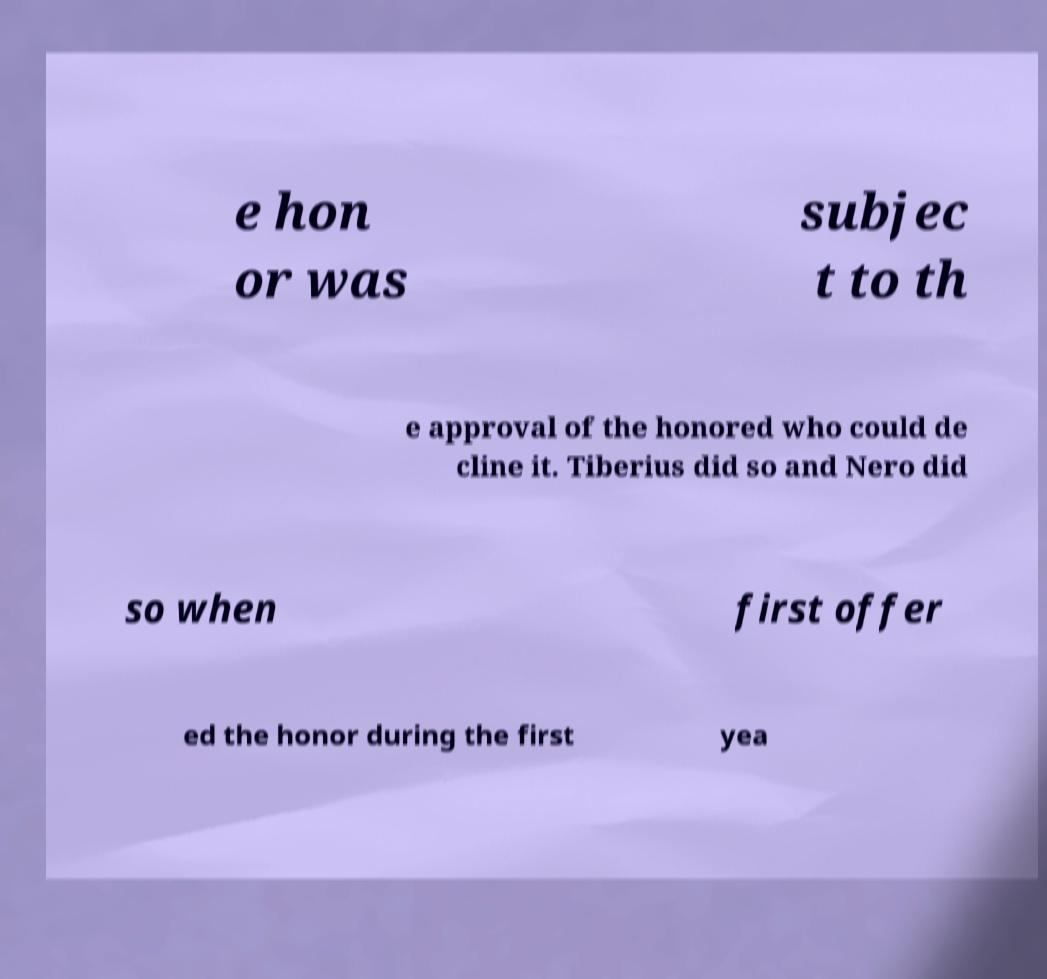Could you assist in decoding the text presented in this image and type it out clearly? e hon or was subjec t to th e approval of the honored who could de cline it. Tiberius did so and Nero did so when first offer ed the honor during the first yea 